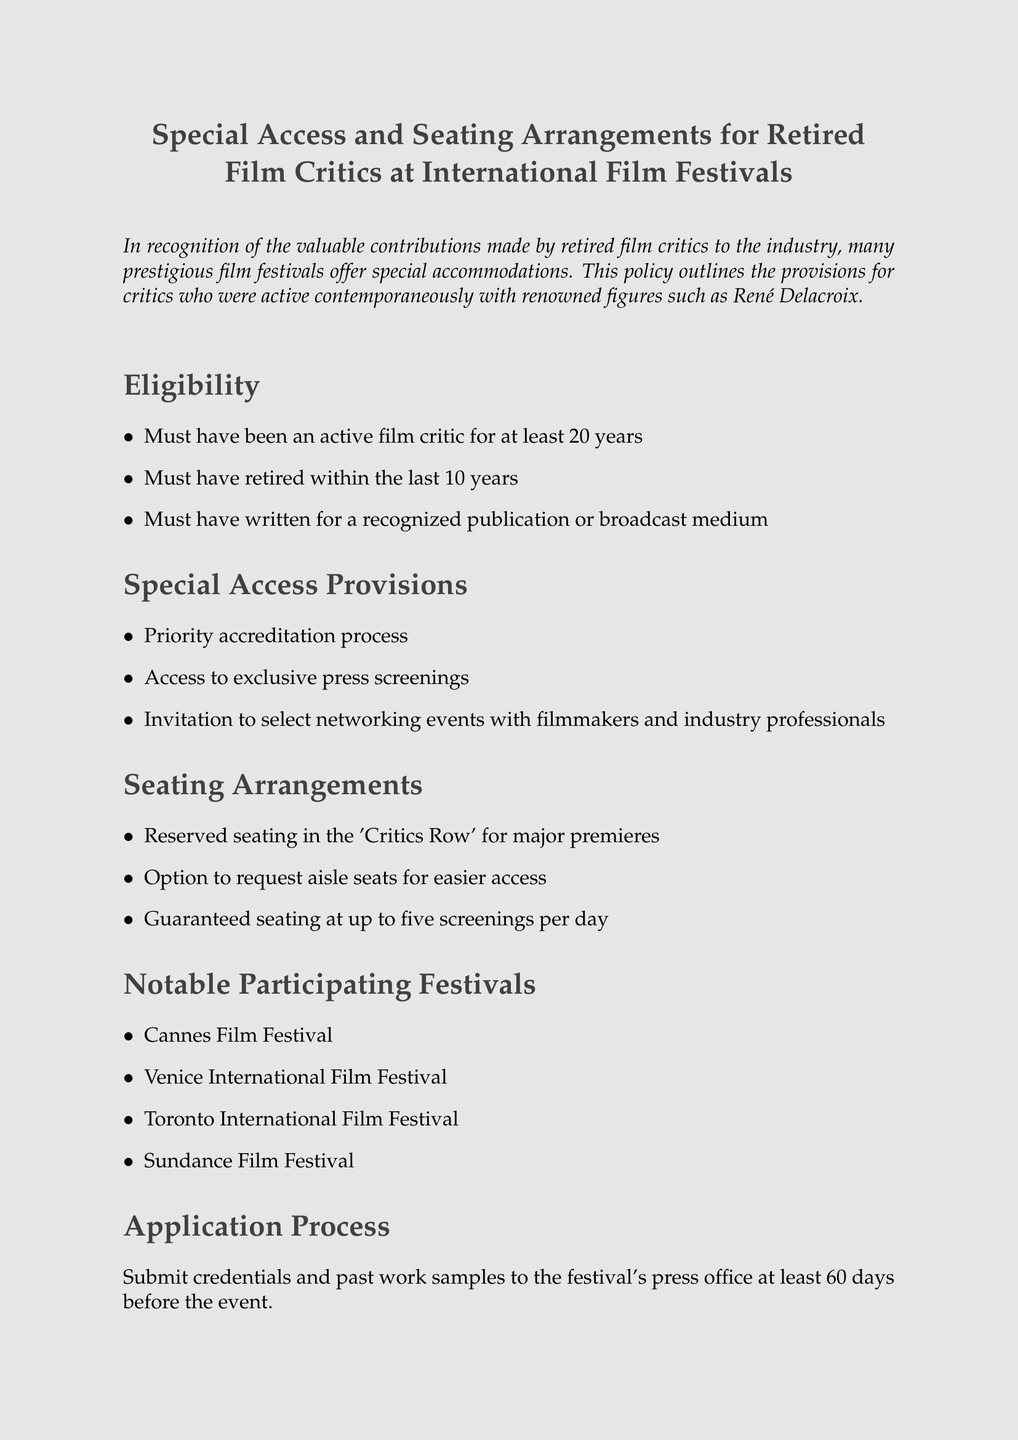What is the minimum active duration required for eligibility? The document states that critics must have been active for at least 20 years to qualify for special access provisions.
Answer: 20 years What is the maximum retirement period for eligibility? It specifies that critics must have retired within the last 10 years to be eligible.
Answer: 10 years What type of seating is guaranteed for critics at screenings? The document mentions that critics are guaranteed seating at up to five screenings per day.
Answer: Five screenings Name one film festival participating in this policy. The document lists several festivals, one example can be drawn from it.
Answer: Cannes Film Festival What is needed to apply for special access? According to the document, critics must submit credentials and past work samples to apply for special access provisions.
Answer: Credentials and work samples What will critics have access to during the film festival? Critics are provided with access to exclusive press screenings as part of their special provisions.
Answer: Exclusive press screenings Which organization should be contacted for inquiries? The contact information given in the document leads to a specific organization for questions related to this policy.
Answer: FIPRESCI Are aisle seats available upon request? The document confirms that critics have the option to request aisle seats for easier access.
Answer: Yes 